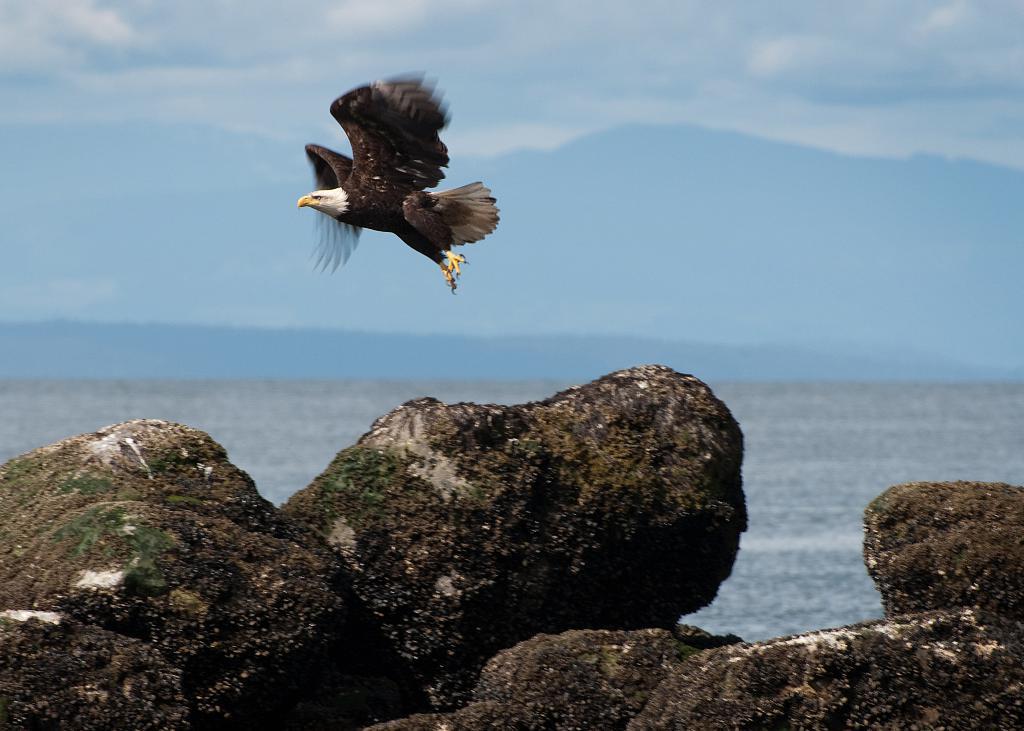Can you describe this image briefly? In the foreground of the image we can see rocks and some water body. In the middle of the image we can see an eagle which is flying. On the top of the image we can see the sky. 